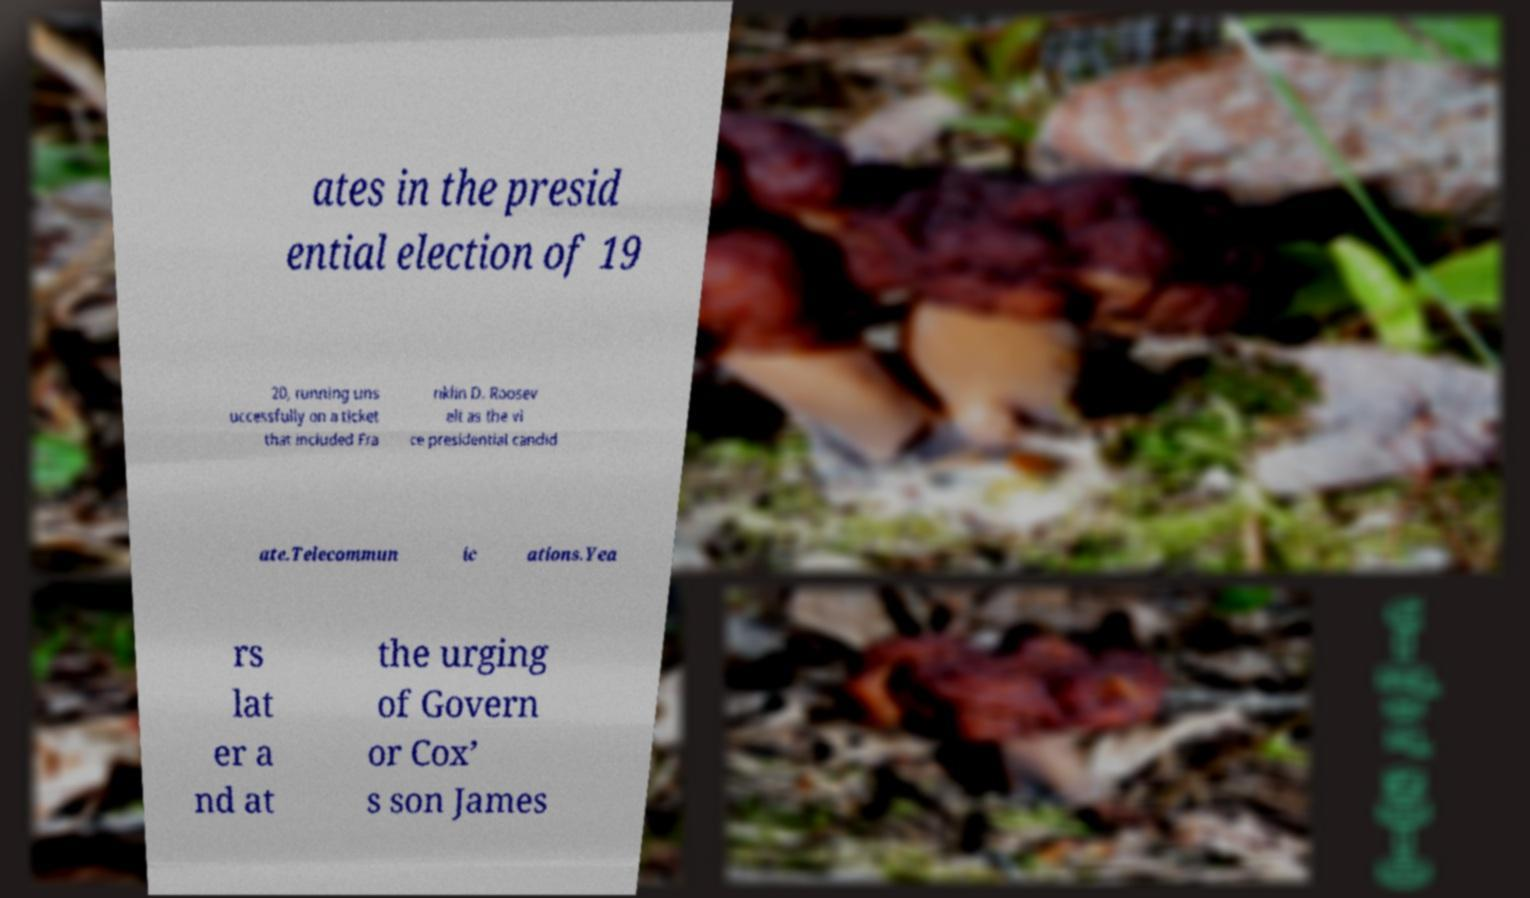I need the written content from this picture converted into text. Can you do that? ates in the presid ential election of 19 20, running uns uccessfully on a ticket that included Fra nklin D. Roosev elt as the vi ce presidential candid ate.Telecommun ic ations.Yea rs lat er a nd at the urging of Govern or Cox’ s son James 